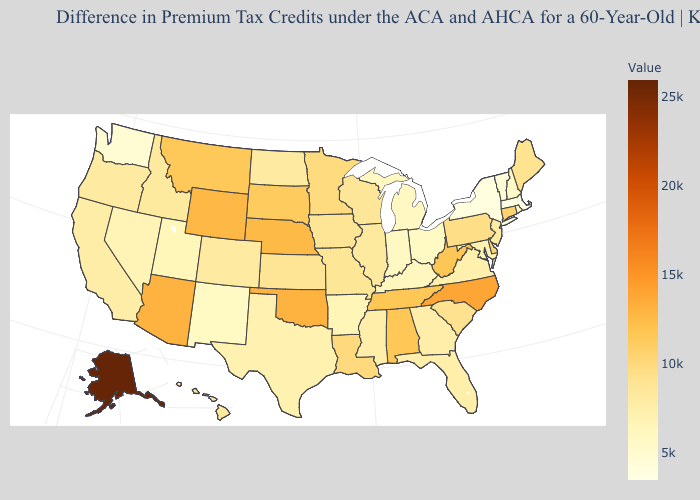Does Alaska have the highest value in the USA?
Answer briefly. Yes. Among the states that border West Virginia , does Pennsylvania have the highest value?
Write a very short answer. Yes. Does the map have missing data?
Be succinct. No. Is the legend a continuous bar?
Short answer required. Yes. Which states have the lowest value in the USA?
Answer briefly. Massachusetts. 